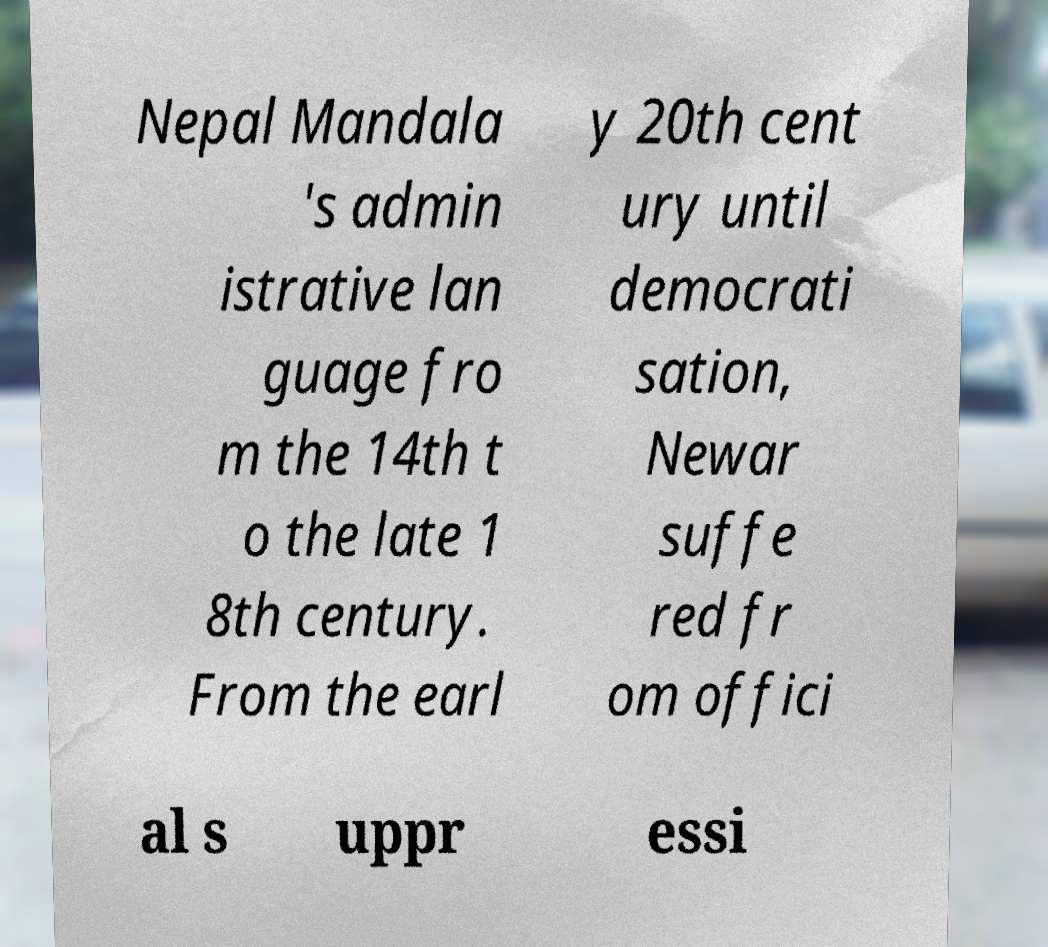I need the written content from this picture converted into text. Can you do that? Nepal Mandala 's admin istrative lan guage fro m the 14th t o the late 1 8th century. From the earl y 20th cent ury until democrati sation, Newar suffe red fr om offici al s uppr essi 